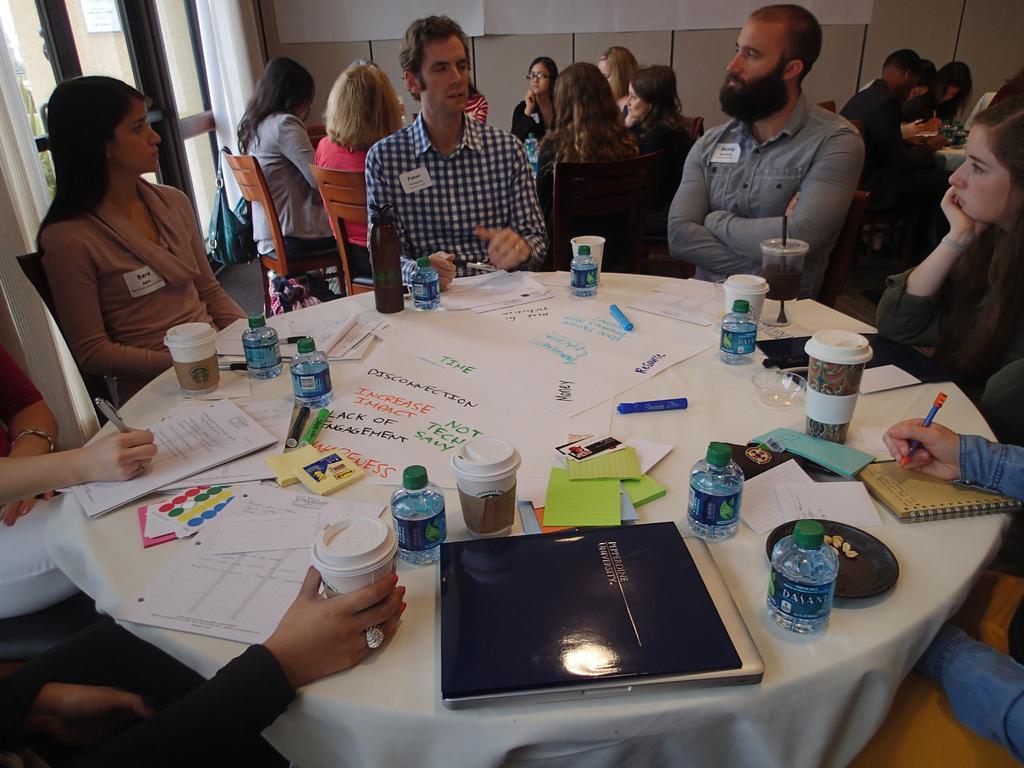Please provide a concise description of this image. In this image I see number of people who are sitting on the chairs and there are tables in front of them and on the table I see lot of papers, bottles, sketches and the cups. In the background I see the curtain and the wall. 